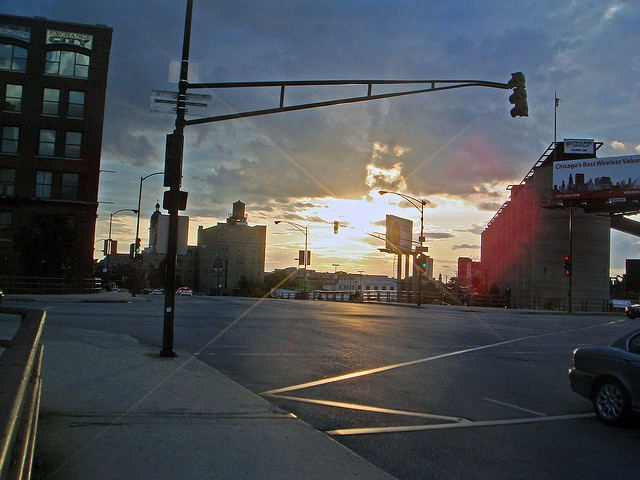Describe the objects in this image and their specific colors. I can see car in darkblue, black, navy, and gray tones, traffic light in darkblue, black, gray, and darkgray tones, car in darkblue, black, gray, and darkgray tones, traffic light in darkblue, maroon, gray, and tan tones, and traffic light in darkblue, black, maroon, brown, and red tones in this image. 